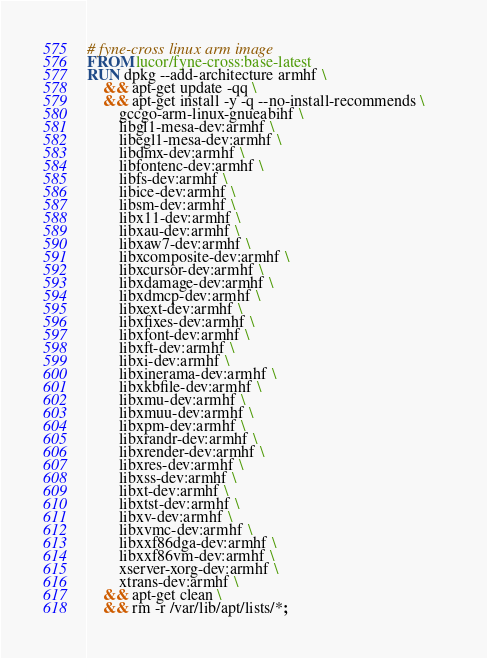Convert code to text. <code><loc_0><loc_0><loc_500><loc_500><_Dockerfile_># fyne-cross linux arm image
FROM lucor/fyne-cross:base-latest
RUN dpkg --add-architecture armhf \
    && apt-get update -qq \
    && apt-get install -y -q --no-install-recommends \     
        gccgo-arm-linux-gnueabihf \
        libgl1-mesa-dev:armhf \
        libegl1-mesa-dev:armhf \
        libdmx-dev:armhf \
        libfontenc-dev:armhf \
        libfs-dev:armhf \
        libice-dev:armhf \
        libsm-dev:armhf \
        libx11-dev:armhf \
        libxau-dev:armhf \
        libxaw7-dev:armhf \
        libxcomposite-dev:armhf \
        libxcursor-dev:armhf \
        libxdamage-dev:armhf \
        libxdmcp-dev:armhf \
        libxext-dev:armhf \
        libxfixes-dev:armhf \
        libxfont-dev:armhf \
        libxft-dev:armhf \
        libxi-dev:armhf \
        libxinerama-dev:armhf \
        libxkbfile-dev:armhf \
        libxmu-dev:armhf \
        libxmuu-dev:armhf \
        libxpm-dev:armhf \
        libxrandr-dev:armhf \
        libxrender-dev:armhf \
        libxres-dev:armhf \
        libxss-dev:armhf \
        libxt-dev:armhf \
        libxtst-dev:armhf \
        libxv-dev:armhf \
        libxvmc-dev:armhf \
        libxxf86dga-dev:armhf \
        libxxf86vm-dev:armhf \
        xserver-xorg-dev:armhf \
        xtrans-dev:armhf \
    && apt-get clean \
    && rm -r /var/lib/apt/lists/*;
</code> 